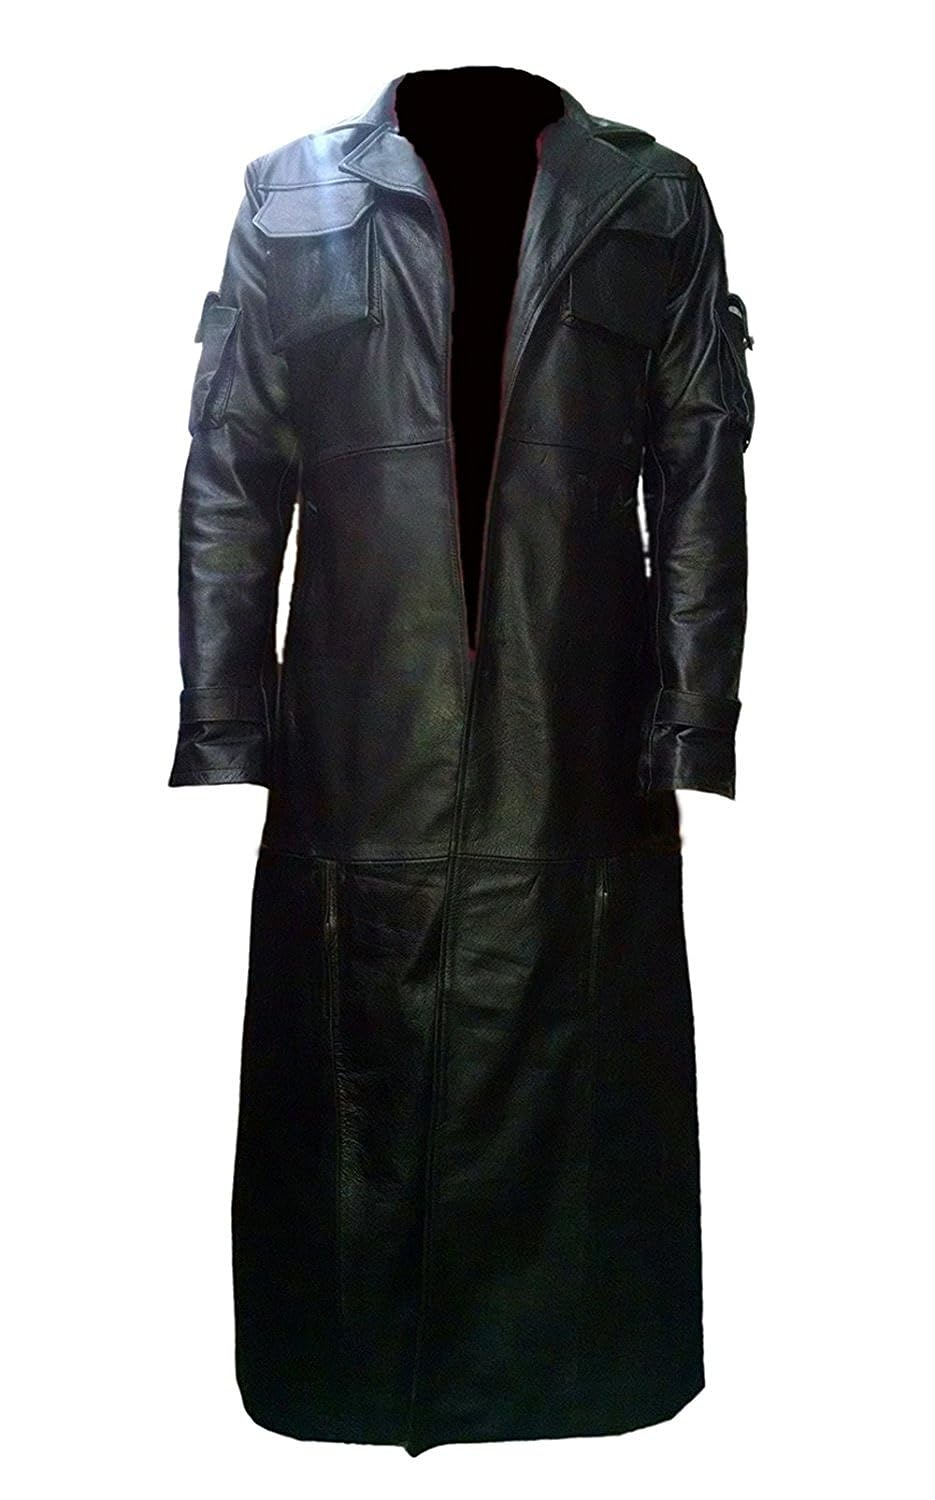Discuss the possible cultural or historical influences evident in the design of this coat. The design of this coat may be influenced by a variety of historical and cultural styles. The structured shoulders and length might suggest influences from historical military uniforms, especially those worn by officers, which often used long coats to signify rank and provide function. The dramatic collar can be linked to Gothic fashion, which embraces dark elegance and complex, ornate aesthetics. Such elements combine to give the coat a timeless appeal that blurs the lines between modern and historical fashion sensibilities. 
How might this coat be styled for a modern, everyday look? To style this coat for a modern, everyday look, it could be paired with streamlined, understated pieces to balance its dramatic silhouette. A simple fitted turtleneck, slim trousers, and minimalist boots would maintain a sleek, contemporary aesthetic without overshadowing the coat’s statement features. Accessories should be kept to a minimum to allow the coat's design to stand out, making the overall outfit sophisticated yet approachable, suitable for city life or stylish evening events. 